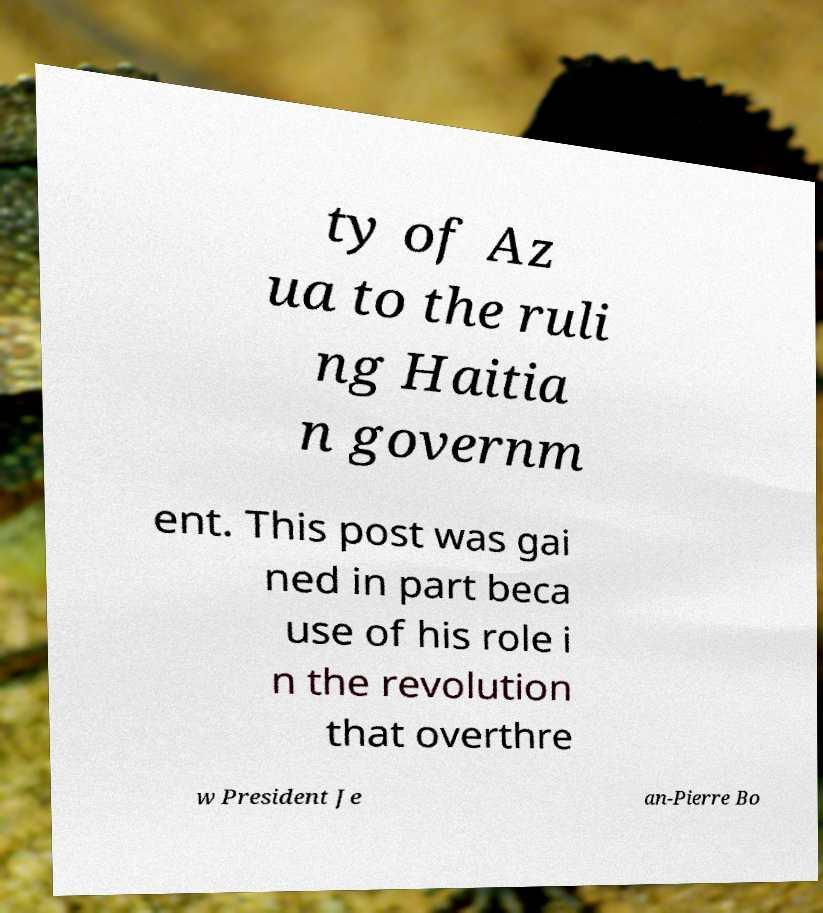Can you read and provide the text displayed in the image?This photo seems to have some interesting text. Can you extract and type it out for me? ty of Az ua to the ruli ng Haitia n governm ent. This post was gai ned in part beca use of his role i n the revolution that overthre w President Je an-Pierre Bo 